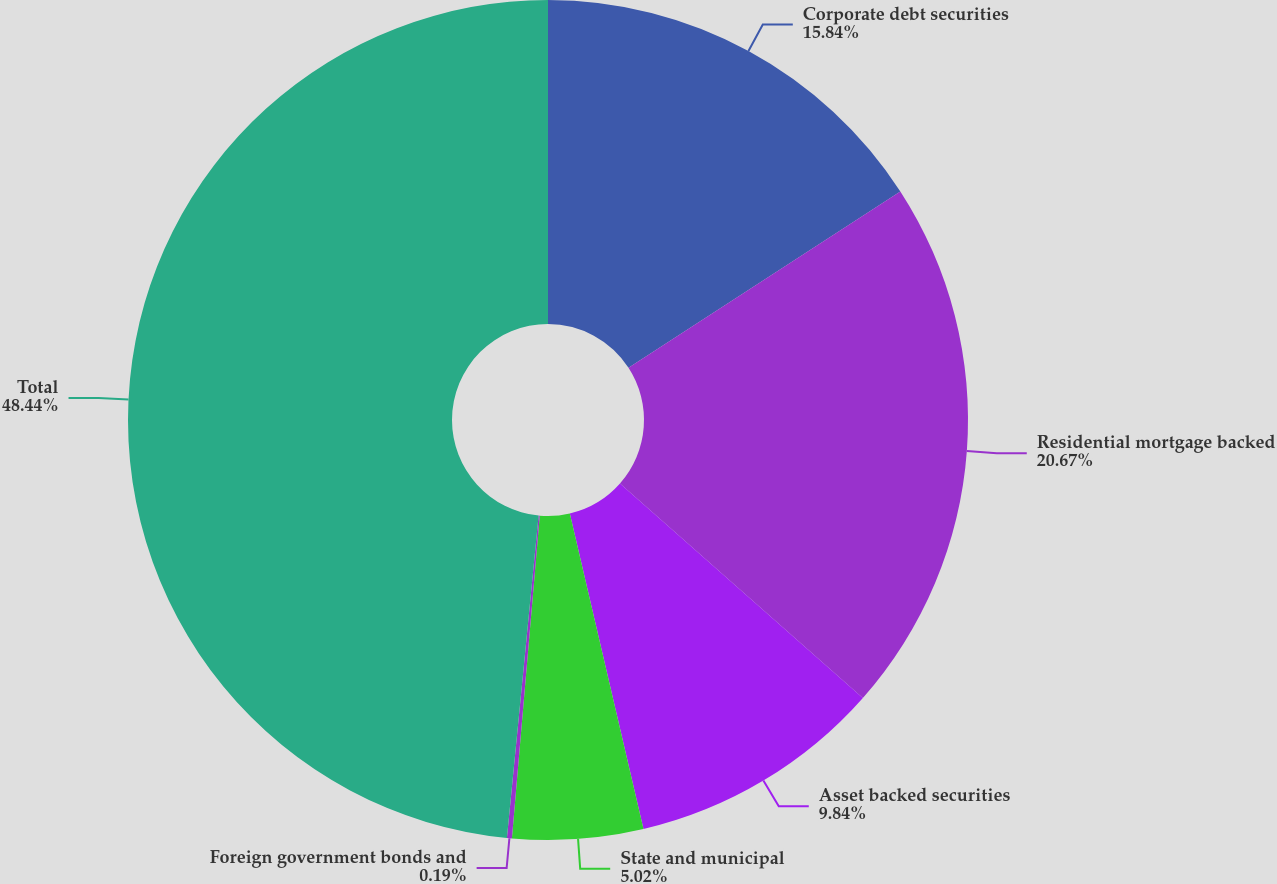Convert chart to OTSL. <chart><loc_0><loc_0><loc_500><loc_500><pie_chart><fcel>Corporate debt securities<fcel>Residential mortgage backed<fcel>Asset backed securities<fcel>State and municipal<fcel>Foreign government bonds and<fcel>Total<nl><fcel>15.84%<fcel>20.67%<fcel>9.84%<fcel>5.02%<fcel>0.19%<fcel>48.44%<nl></chart> 